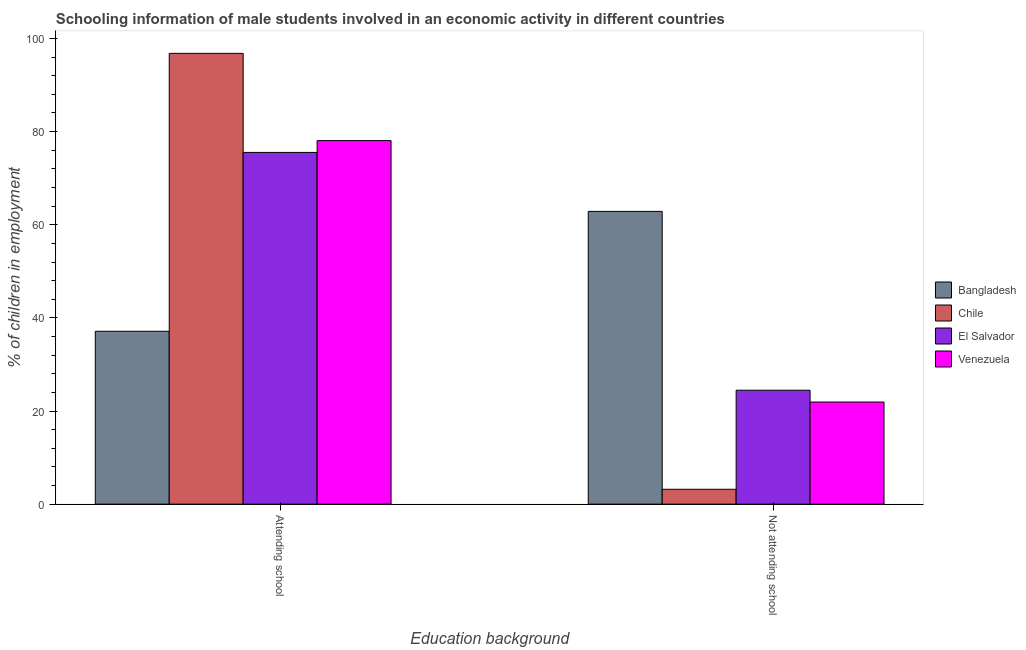How many different coloured bars are there?
Your answer should be very brief. 4. How many bars are there on the 1st tick from the left?
Give a very brief answer. 4. How many bars are there on the 2nd tick from the right?
Offer a very short reply. 4. What is the label of the 2nd group of bars from the left?
Provide a short and direct response. Not attending school. What is the percentage of employed males who are not attending school in Chile?
Provide a succinct answer. 3.19. Across all countries, what is the maximum percentage of employed males who are not attending school?
Give a very brief answer. 62.87. Across all countries, what is the minimum percentage of employed males who are attending school?
Keep it short and to the point. 37.13. In which country was the percentage of employed males who are not attending school minimum?
Provide a succinct answer. Chile. What is the total percentage of employed males who are attending school in the graph?
Offer a very short reply. 287.54. What is the difference between the percentage of employed males who are not attending school in Bangladesh and that in Chile?
Your response must be concise. 59.68. What is the difference between the percentage of employed males who are not attending school in El Salvador and the percentage of employed males who are attending school in Bangladesh?
Give a very brief answer. -12.66. What is the average percentage of employed males who are attending school per country?
Make the answer very short. 71.88. What is the difference between the percentage of employed males who are attending school and percentage of employed males who are not attending school in El Salvador?
Offer a terse response. 51.07. What is the ratio of the percentage of employed males who are attending school in Chile to that in Venezuela?
Your response must be concise. 1.24. In how many countries, is the percentage of employed males who are attending school greater than the average percentage of employed males who are attending school taken over all countries?
Ensure brevity in your answer.  3. How many countries are there in the graph?
Ensure brevity in your answer.  4. What is the difference between two consecutive major ticks on the Y-axis?
Provide a short and direct response. 20. Does the graph contain grids?
Your answer should be very brief. No. What is the title of the graph?
Keep it short and to the point. Schooling information of male students involved in an economic activity in different countries. Does "Finland" appear as one of the legend labels in the graph?
Provide a succinct answer. No. What is the label or title of the X-axis?
Provide a succinct answer. Education background. What is the label or title of the Y-axis?
Give a very brief answer. % of children in employment. What is the % of children in employment of Bangladesh in Attending school?
Provide a short and direct response. 37.13. What is the % of children in employment in Chile in Attending school?
Offer a terse response. 96.81. What is the % of children in employment in El Salvador in Attending school?
Your response must be concise. 75.53. What is the % of children in employment in Venezuela in Attending school?
Your response must be concise. 78.07. What is the % of children in employment in Bangladesh in Not attending school?
Provide a short and direct response. 62.87. What is the % of children in employment of Chile in Not attending school?
Your response must be concise. 3.19. What is the % of children in employment of El Salvador in Not attending school?
Provide a succinct answer. 24.47. What is the % of children in employment of Venezuela in Not attending school?
Keep it short and to the point. 21.93. Across all Education background, what is the maximum % of children in employment of Bangladesh?
Ensure brevity in your answer.  62.87. Across all Education background, what is the maximum % of children in employment in Chile?
Keep it short and to the point. 96.81. Across all Education background, what is the maximum % of children in employment in El Salvador?
Ensure brevity in your answer.  75.53. Across all Education background, what is the maximum % of children in employment in Venezuela?
Your response must be concise. 78.07. Across all Education background, what is the minimum % of children in employment of Bangladesh?
Give a very brief answer. 37.13. Across all Education background, what is the minimum % of children in employment in Chile?
Ensure brevity in your answer.  3.19. Across all Education background, what is the minimum % of children in employment in El Salvador?
Ensure brevity in your answer.  24.47. Across all Education background, what is the minimum % of children in employment in Venezuela?
Provide a succinct answer. 21.93. What is the total % of children in employment in Chile in the graph?
Make the answer very short. 100. What is the total % of children in employment of El Salvador in the graph?
Offer a terse response. 100. What is the total % of children in employment of Venezuela in the graph?
Keep it short and to the point. 100. What is the difference between the % of children in employment in Bangladesh in Attending school and that in Not attending school?
Ensure brevity in your answer.  -25.74. What is the difference between the % of children in employment of Chile in Attending school and that in Not attending school?
Offer a very short reply. 93.61. What is the difference between the % of children in employment of El Salvador in Attending school and that in Not attending school?
Your response must be concise. 51.07. What is the difference between the % of children in employment in Venezuela in Attending school and that in Not attending school?
Provide a short and direct response. 56.14. What is the difference between the % of children in employment in Bangladesh in Attending school and the % of children in employment in Chile in Not attending school?
Offer a terse response. 33.94. What is the difference between the % of children in employment in Bangladesh in Attending school and the % of children in employment in El Salvador in Not attending school?
Give a very brief answer. 12.66. What is the difference between the % of children in employment in Bangladesh in Attending school and the % of children in employment in Venezuela in Not attending school?
Keep it short and to the point. 15.2. What is the difference between the % of children in employment of Chile in Attending school and the % of children in employment of El Salvador in Not attending school?
Your answer should be very brief. 72.34. What is the difference between the % of children in employment of Chile in Attending school and the % of children in employment of Venezuela in Not attending school?
Your answer should be compact. 74.88. What is the difference between the % of children in employment in El Salvador in Attending school and the % of children in employment in Venezuela in Not attending school?
Make the answer very short. 53.6. What is the average % of children in employment of Bangladesh per Education background?
Provide a succinct answer. 50. What is the difference between the % of children in employment in Bangladesh and % of children in employment in Chile in Attending school?
Your answer should be compact. -59.68. What is the difference between the % of children in employment in Bangladesh and % of children in employment in El Salvador in Attending school?
Your response must be concise. -38.4. What is the difference between the % of children in employment of Bangladesh and % of children in employment of Venezuela in Attending school?
Keep it short and to the point. -40.94. What is the difference between the % of children in employment of Chile and % of children in employment of El Salvador in Attending school?
Provide a succinct answer. 21.27. What is the difference between the % of children in employment of Chile and % of children in employment of Venezuela in Attending school?
Provide a succinct answer. 18.74. What is the difference between the % of children in employment of El Salvador and % of children in employment of Venezuela in Attending school?
Ensure brevity in your answer.  -2.54. What is the difference between the % of children in employment in Bangladesh and % of children in employment in Chile in Not attending school?
Provide a succinct answer. 59.68. What is the difference between the % of children in employment of Bangladesh and % of children in employment of El Salvador in Not attending school?
Give a very brief answer. 38.4. What is the difference between the % of children in employment of Bangladesh and % of children in employment of Venezuela in Not attending school?
Your answer should be very brief. 40.94. What is the difference between the % of children in employment of Chile and % of children in employment of El Salvador in Not attending school?
Give a very brief answer. -21.27. What is the difference between the % of children in employment in Chile and % of children in employment in Venezuela in Not attending school?
Make the answer very short. -18.74. What is the difference between the % of children in employment of El Salvador and % of children in employment of Venezuela in Not attending school?
Your answer should be compact. 2.54. What is the ratio of the % of children in employment in Bangladesh in Attending school to that in Not attending school?
Provide a short and direct response. 0.59. What is the ratio of the % of children in employment of Chile in Attending school to that in Not attending school?
Offer a terse response. 30.31. What is the ratio of the % of children in employment of El Salvador in Attending school to that in Not attending school?
Provide a short and direct response. 3.09. What is the ratio of the % of children in employment of Venezuela in Attending school to that in Not attending school?
Ensure brevity in your answer.  3.56. What is the difference between the highest and the second highest % of children in employment in Bangladesh?
Offer a very short reply. 25.74. What is the difference between the highest and the second highest % of children in employment in Chile?
Provide a succinct answer. 93.61. What is the difference between the highest and the second highest % of children in employment of El Salvador?
Provide a short and direct response. 51.07. What is the difference between the highest and the second highest % of children in employment in Venezuela?
Offer a terse response. 56.14. What is the difference between the highest and the lowest % of children in employment of Bangladesh?
Offer a terse response. 25.74. What is the difference between the highest and the lowest % of children in employment of Chile?
Offer a terse response. 93.61. What is the difference between the highest and the lowest % of children in employment in El Salvador?
Offer a very short reply. 51.07. What is the difference between the highest and the lowest % of children in employment of Venezuela?
Give a very brief answer. 56.14. 